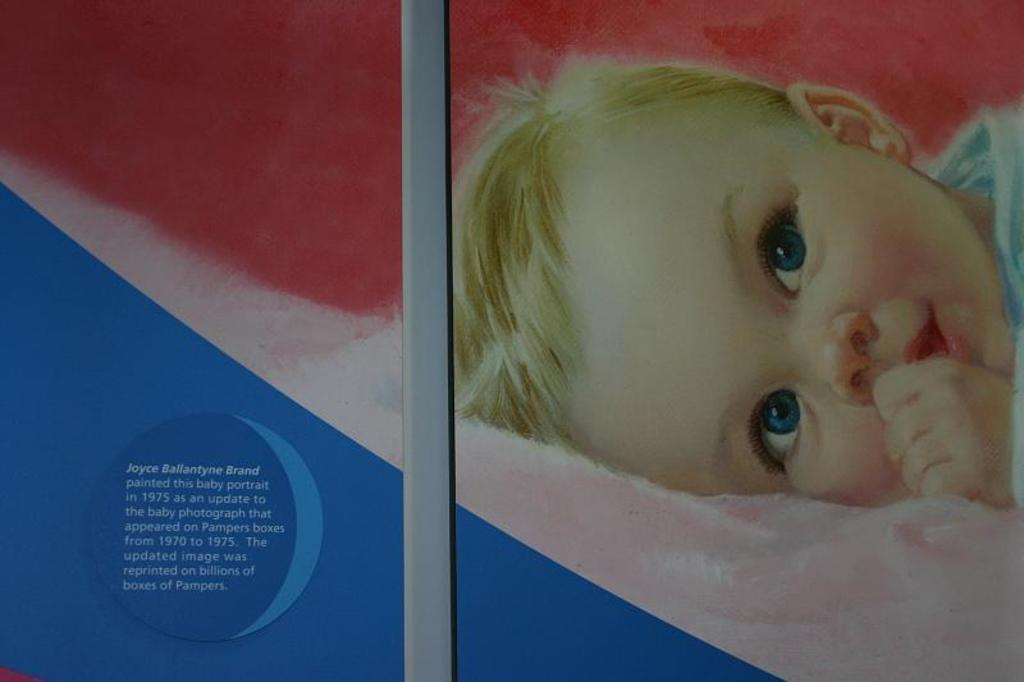What type of artwork is depicted in the image? The image is a painting. Who or what is the main subject of the painting? There is a kid in the painting. What else can be seen in the painting besides the kid? There is a cloth and text in the painting. What type of fruit is hanging from the cloth in the painting? There is no fruit present in the painting; it only features a kid, a cloth, and text. 